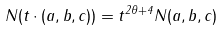Convert formula to latex. <formula><loc_0><loc_0><loc_500><loc_500>N ( t \cdot ( a , b , c ) ) = t ^ { 2 \theta + 4 } N ( a , b , c )</formula> 